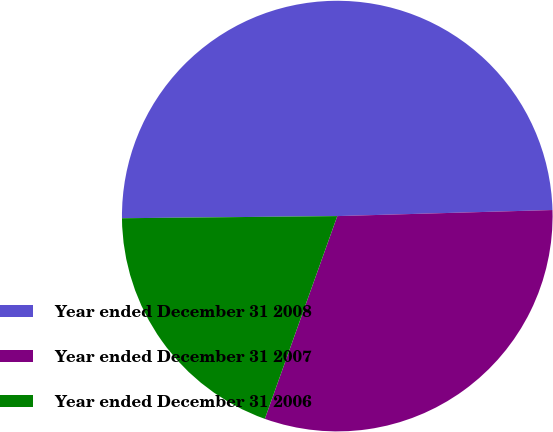<chart> <loc_0><loc_0><loc_500><loc_500><pie_chart><fcel>Year ended December 31 2008<fcel>Year ended December 31 2007<fcel>Year ended December 31 2006<nl><fcel>49.71%<fcel>30.91%<fcel>19.38%<nl></chart> 